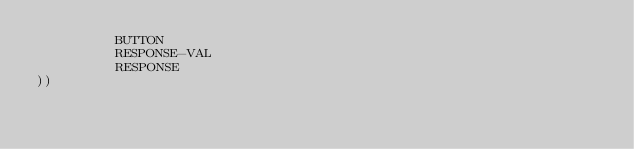<code> <loc_0><loc_0><loc_500><loc_500><_Lisp_>          BUTTON
          RESPONSE-VAL
          RESPONSE
))</code> 